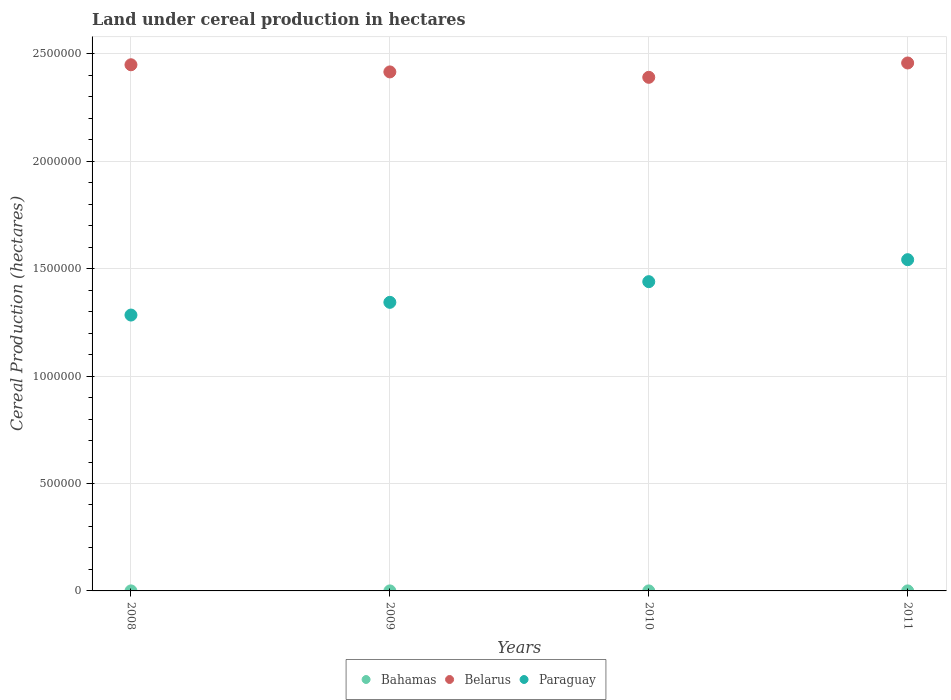How many different coloured dotlines are there?
Keep it short and to the point. 3. Is the number of dotlines equal to the number of legend labels?
Give a very brief answer. Yes. What is the land under cereal production in Belarus in 2010?
Make the answer very short. 2.39e+06. Across all years, what is the maximum land under cereal production in Paraguay?
Give a very brief answer. 1.54e+06. Across all years, what is the minimum land under cereal production in Paraguay?
Your response must be concise. 1.28e+06. In which year was the land under cereal production in Belarus maximum?
Make the answer very short. 2011. In which year was the land under cereal production in Belarus minimum?
Keep it short and to the point. 2010. What is the total land under cereal production in Paraguay in the graph?
Offer a very short reply. 5.61e+06. What is the difference between the land under cereal production in Paraguay in 2008 and that in 2011?
Give a very brief answer. -2.58e+05. What is the difference between the land under cereal production in Bahamas in 2009 and the land under cereal production in Belarus in 2008?
Your answer should be compact. -2.45e+06. What is the average land under cereal production in Paraguay per year?
Keep it short and to the point. 1.40e+06. In the year 2009, what is the difference between the land under cereal production in Belarus and land under cereal production in Bahamas?
Your answer should be compact. 2.42e+06. What is the ratio of the land under cereal production in Belarus in 2009 to that in 2010?
Your response must be concise. 1.01. Is the land under cereal production in Bahamas in 2008 less than that in 2011?
Keep it short and to the point. No. Is the difference between the land under cereal production in Belarus in 2008 and 2010 greater than the difference between the land under cereal production in Bahamas in 2008 and 2010?
Your answer should be very brief. Yes. What is the difference between the highest and the second highest land under cereal production in Bahamas?
Offer a very short reply. 5. What is the difference between the highest and the lowest land under cereal production in Bahamas?
Give a very brief answer. 15. Does the land under cereal production in Belarus monotonically increase over the years?
Offer a very short reply. No. Is the land under cereal production in Paraguay strictly less than the land under cereal production in Belarus over the years?
Keep it short and to the point. Yes. How many dotlines are there?
Give a very brief answer. 3. How many years are there in the graph?
Give a very brief answer. 4. Does the graph contain grids?
Give a very brief answer. Yes. Where does the legend appear in the graph?
Ensure brevity in your answer.  Bottom center. How many legend labels are there?
Offer a very short reply. 3. How are the legend labels stacked?
Offer a terse response. Horizontal. What is the title of the graph?
Offer a terse response. Land under cereal production in hectares. Does "High income: nonOECD" appear as one of the legend labels in the graph?
Offer a terse response. No. What is the label or title of the Y-axis?
Provide a succinct answer. Cereal Production (hectares). What is the Cereal Production (hectares) in Bahamas in 2008?
Make the answer very short. 105. What is the Cereal Production (hectares) in Belarus in 2008?
Offer a terse response. 2.45e+06. What is the Cereal Production (hectares) of Paraguay in 2008?
Make the answer very short. 1.28e+06. What is the Cereal Production (hectares) of Bahamas in 2009?
Your answer should be compact. 100. What is the Cereal Production (hectares) of Belarus in 2009?
Offer a very short reply. 2.42e+06. What is the Cereal Production (hectares) of Paraguay in 2009?
Make the answer very short. 1.34e+06. What is the Cereal Production (hectares) of Bahamas in 2010?
Offer a terse response. 90. What is the Cereal Production (hectares) in Belarus in 2010?
Your answer should be compact. 2.39e+06. What is the Cereal Production (hectares) in Paraguay in 2010?
Your answer should be very brief. 1.44e+06. What is the Cereal Production (hectares) of Bahamas in 2011?
Provide a succinct answer. 94. What is the Cereal Production (hectares) of Belarus in 2011?
Keep it short and to the point. 2.46e+06. What is the Cereal Production (hectares) of Paraguay in 2011?
Provide a succinct answer. 1.54e+06. Across all years, what is the maximum Cereal Production (hectares) of Bahamas?
Offer a terse response. 105. Across all years, what is the maximum Cereal Production (hectares) of Belarus?
Make the answer very short. 2.46e+06. Across all years, what is the maximum Cereal Production (hectares) in Paraguay?
Your response must be concise. 1.54e+06. Across all years, what is the minimum Cereal Production (hectares) of Bahamas?
Your answer should be compact. 90. Across all years, what is the minimum Cereal Production (hectares) in Belarus?
Your answer should be compact. 2.39e+06. Across all years, what is the minimum Cereal Production (hectares) of Paraguay?
Keep it short and to the point. 1.28e+06. What is the total Cereal Production (hectares) in Bahamas in the graph?
Ensure brevity in your answer.  389. What is the total Cereal Production (hectares) in Belarus in the graph?
Your answer should be compact. 9.71e+06. What is the total Cereal Production (hectares) of Paraguay in the graph?
Provide a succinct answer. 5.61e+06. What is the difference between the Cereal Production (hectares) of Belarus in 2008 and that in 2009?
Your response must be concise. 3.33e+04. What is the difference between the Cereal Production (hectares) in Paraguay in 2008 and that in 2009?
Your response must be concise. -5.92e+04. What is the difference between the Cereal Production (hectares) of Bahamas in 2008 and that in 2010?
Your answer should be compact. 15. What is the difference between the Cereal Production (hectares) in Belarus in 2008 and that in 2010?
Your response must be concise. 5.84e+04. What is the difference between the Cereal Production (hectares) in Paraguay in 2008 and that in 2010?
Your response must be concise. -1.55e+05. What is the difference between the Cereal Production (hectares) in Belarus in 2008 and that in 2011?
Keep it short and to the point. -8339. What is the difference between the Cereal Production (hectares) in Paraguay in 2008 and that in 2011?
Keep it short and to the point. -2.58e+05. What is the difference between the Cereal Production (hectares) in Belarus in 2009 and that in 2010?
Provide a short and direct response. 2.52e+04. What is the difference between the Cereal Production (hectares) in Paraguay in 2009 and that in 2010?
Offer a very short reply. -9.62e+04. What is the difference between the Cereal Production (hectares) of Bahamas in 2009 and that in 2011?
Your response must be concise. 6. What is the difference between the Cereal Production (hectares) of Belarus in 2009 and that in 2011?
Offer a very short reply. -4.16e+04. What is the difference between the Cereal Production (hectares) of Paraguay in 2009 and that in 2011?
Provide a succinct answer. -1.99e+05. What is the difference between the Cereal Production (hectares) in Bahamas in 2010 and that in 2011?
Keep it short and to the point. -4. What is the difference between the Cereal Production (hectares) of Belarus in 2010 and that in 2011?
Ensure brevity in your answer.  -6.68e+04. What is the difference between the Cereal Production (hectares) of Paraguay in 2010 and that in 2011?
Ensure brevity in your answer.  -1.02e+05. What is the difference between the Cereal Production (hectares) of Bahamas in 2008 and the Cereal Production (hectares) of Belarus in 2009?
Offer a terse response. -2.42e+06. What is the difference between the Cereal Production (hectares) of Bahamas in 2008 and the Cereal Production (hectares) of Paraguay in 2009?
Give a very brief answer. -1.34e+06. What is the difference between the Cereal Production (hectares) of Belarus in 2008 and the Cereal Production (hectares) of Paraguay in 2009?
Provide a short and direct response. 1.11e+06. What is the difference between the Cereal Production (hectares) in Bahamas in 2008 and the Cereal Production (hectares) in Belarus in 2010?
Provide a succinct answer. -2.39e+06. What is the difference between the Cereal Production (hectares) in Bahamas in 2008 and the Cereal Production (hectares) in Paraguay in 2010?
Your answer should be very brief. -1.44e+06. What is the difference between the Cereal Production (hectares) in Belarus in 2008 and the Cereal Production (hectares) in Paraguay in 2010?
Keep it short and to the point. 1.01e+06. What is the difference between the Cereal Production (hectares) in Bahamas in 2008 and the Cereal Production (hectares) in Belarus in 2011?
Provide a succinct answer. -2.46e+06. What is the difference between the Cereal Production (hectares) in Bahamas in 2008 and the Cereal Production (hectares) in Paraguay in 2011?
Offer a terse response. -1.54e+06. What is the difference between the Cereal Production (hectares) of Belarus in 2008 and the Cereal Production (hectares) of Paraguay in 2011?
Keep it short and to the point. 9.07e+05. What is the difference between the Cereal Production (hectares) in Bahamas in 2009 and the Cereal Production (hectares) in Belarus in 2010?
Provide a succinct answer. -2.39e+06. What is the difference between the Cereal Production (hectares) in Bahamas in 2009 and the Cereal Production (hectares) in Paraguay in 2010?
Your answer should be very brief. -1.44e+06. What is the difference between the Cereal Production (hectares) of Belarus in 2009 and the Cereal Production (hectares) of Paraguay in 2010?
Your response must be concise. 9.76e+05. What is the difference between the Cereal Production (hectares) in Bahamas in 2009 and the Cereal Production (hectares) in Belarus in 2011?
Your answer should be very brief. -2.46e+06. What is the difference between the Cereal Production (hectares) of Bahamas in 2009 and the Cereal Production (hectares) of Paraguay in 2011?
Your answer should be compact. -1.54e+06. What is the difference between the Cereal Production (hectares) in Belarus in 2009 and the Cereal Production (hectares) in Paraguay in 2011?
Your answer should be compact. 8.74e+05. What is the difference between the Cereal Production (hectares) in Bahamas in 2010 and the Cereal Production (hectares) in Belarus in 2011?
Your response must be concise. -2.46e+06. What is the difference between the Cereal Production (hectares) in Bahamas in 2010 and the Cereal Production (hectares) in Paraguay in 2011?
Your answer should be very brief. -1.54e+06. What is the difference between the Cereal Production (hectares) of Belarus in 2010 and the Cereal Production (hectares) of Paraguay in 2011?
Provide a succinct answer. 8.49e+05. What is the average Cereal Production (hectares) of Bahamas per year?
Make the answer very short. 97.25. What is the average Cereal Production (hectares) of Belarus per year?
Give a very brief answer. 2.43e+06. What is the average Cereal Production (hectares) in Paraguay per year?
Make the answer very short. 1.40e+06. In the year 2008, what is the difference between the Cereal Production (hectares) of Bahamas and Cereal Production (hectares) of Belarus?
Your answer should be very brief. -2.45e+06. In the year 2008, what is the difference between the Cereal Production (hectares) in Bahamas and Cereal Production (hectares) in Paraguay?
Provide a short and direct response. -1.28e+06. In the year 2008, what is the difference between the Cereal Production (hectares) in Belarus and Cereal Production (hectares) in Paraguay?
Offer a terse response. 1.16e+06. In the year 2009, what is the difference between the Cereal Production (hectares) in Bahamas and Cereal Production (hectares) in Belarus?
Your answer should be very brief. -2.42e+06. In the year 2009, what is the difference between the Cereal Production (hectares) in Bahamas and Cereal Production (hectares) in Paraguay?
Make the answer very short. -1.34e+06. In the year 2009, what is the difference between the Cereal Production (hectares) in Belarus and Cereal Production (hectares) in Paraguay?
Offer a terse response. 1.07e+06. In the year 2010, what is the difference between the Cereal Production (hectares) of Bahamas and Cereal Production (hectares) of Belarus?
Make the answer very short. -2.39e+06. In the year 2010, what is the difference between the Cereal Production (hectares) of Bahamas and Cereal Production (hectares) of Paraguay?
Keep it short and to the point. -1.44e+06. In the year 2010, what is the difference between the Cereal Production (hectares) of Belarus and Cereal Production (hectares) of Paraguay?
Offer a very short reply. 9.51e+05. In the year 2011, what is the difference between the Cereal Production (hectares) of Bahamas and Cereal Production (hectares) of Belarus?
Your answer should be compact. -2.46e+06. In the year 2011, what is the difference between the Cereal Production (hectares) in Bahamas and Cereal Production (hectares) in Paraguay?
Your answer should be very brief. -1.54e+06. In the year 2011, what is the difference between the Cereal Production (hectares) in Belarus and Cereal Production (hectares) in Paraguay?
Make the answer very short. 9.16e+05. What is the ratio of the Cereal Production (hectares) of Bahamas in 2008 to that in 2009?
Your answer should be very brief. 1.05. What is the ratio of the Cereal Production (hectares) in Belarus in 2008 to that in 2009?
Give a very brief answer. 1.01. What is the ratio of the Cereal Production (hectares) in Paraguay in 2008 to that in 2009?
Provide a succinct answer. 0.96. What is the ratio of the Cereal Production (hectares) in Belarus in 2008 to that in 2010?
Offer a terse response. 1.02. What is the ratio of the Cereal Production (hectares) in Paraguay in 2008 to that in 2010?
Make the answer very short. 0.89. What is the ratio of the Cereal Production (hectares) in Bahamas in 2008 to that in 2011?
Your response must be concise. 1.12. What is the ratio of the Cereal Production (hectares) in Paraguay in 2008 to that in 2011?
Your answer should be compact. 0.83. What is the ratio of the Cereal Production (hectares) in Belarus in 2009 to that in 2010?
Ensure brevity in your answer.  1.01. What is the ratio of the Cereal Production (hectares) of Paraguay in 2009 to that in 2010?
Provide a succinct answer. 0.93. What is the ratio of the Cereal Production (hectares) in Bahamas in 2009 to that in 2011?
Provide a short and direct response. 1.06. What is the ratio of the Cereal Production (hectares) in Belarus in 2009 to that in 2011?
Your response must be concise. 0.98. What is the ratio of the Cereal Production (hectares) of Paraguay in 2009 to that in 2011?
Your response must be concise. 0.87. What is the ratio of the Cereal Production (hectares) of Bahamas in 2010 to that in 2011?
Provide a succinct answer. 0.96. What is the ratio of the Cereal Production (hectares) in Belarus in 2010 to that in 2011?
Provide a succinct answer. 0.97. What is the ratio of the Cereal Production (hectares) of Paraguay in 2010 to that in 2011?
Offer a very short reply. 0.93. What is the difference between the highest and the second highest Cereal Production (hectares) of Bahamas?
Your answer should be compact. 5. What is the difference between the highest and the second highest Cereal Production (hectares) of Belarus?
Your response must be concise. 8339. What is the difference between the highest and the second highest Cereal Production (hectares) in Paraguay?
Offer a very short reply. 1.02e+05. What is the difference between the highest and the lowest Cereal Production (hectares) in Belarus?
Your answer should be compact. 6.68e+04. What is the difference between the highest and the lowest Cereal Production (hectares) of Paraguay?
Provide a short and direct response. 2.58e+05. 